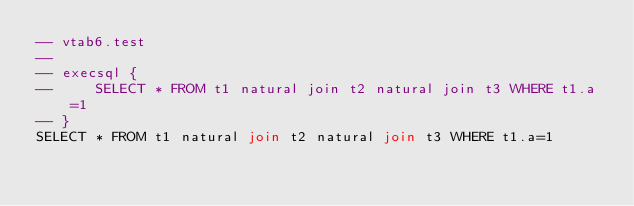<code> <loc_0><loc_0><loc_500><loc_500><_SQL_>-- vtab6.test
-- 
-- execsql {
--     SELECT * FROM t1 natural join t2 natural join t3 WHERE t1.a=1
-- }
SELECT * FROM t1 natural join t2 natural join t3 WHERE t1.a=1</code> 